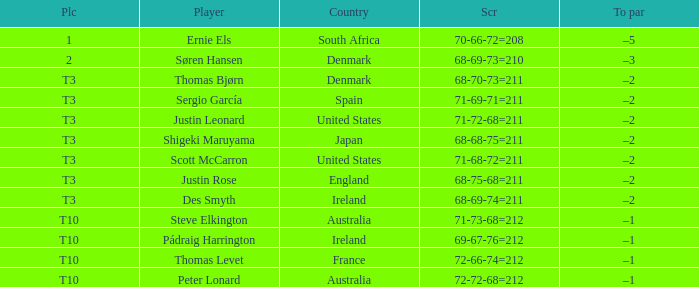What was the place when the score was 68-75-68=211? T3. 